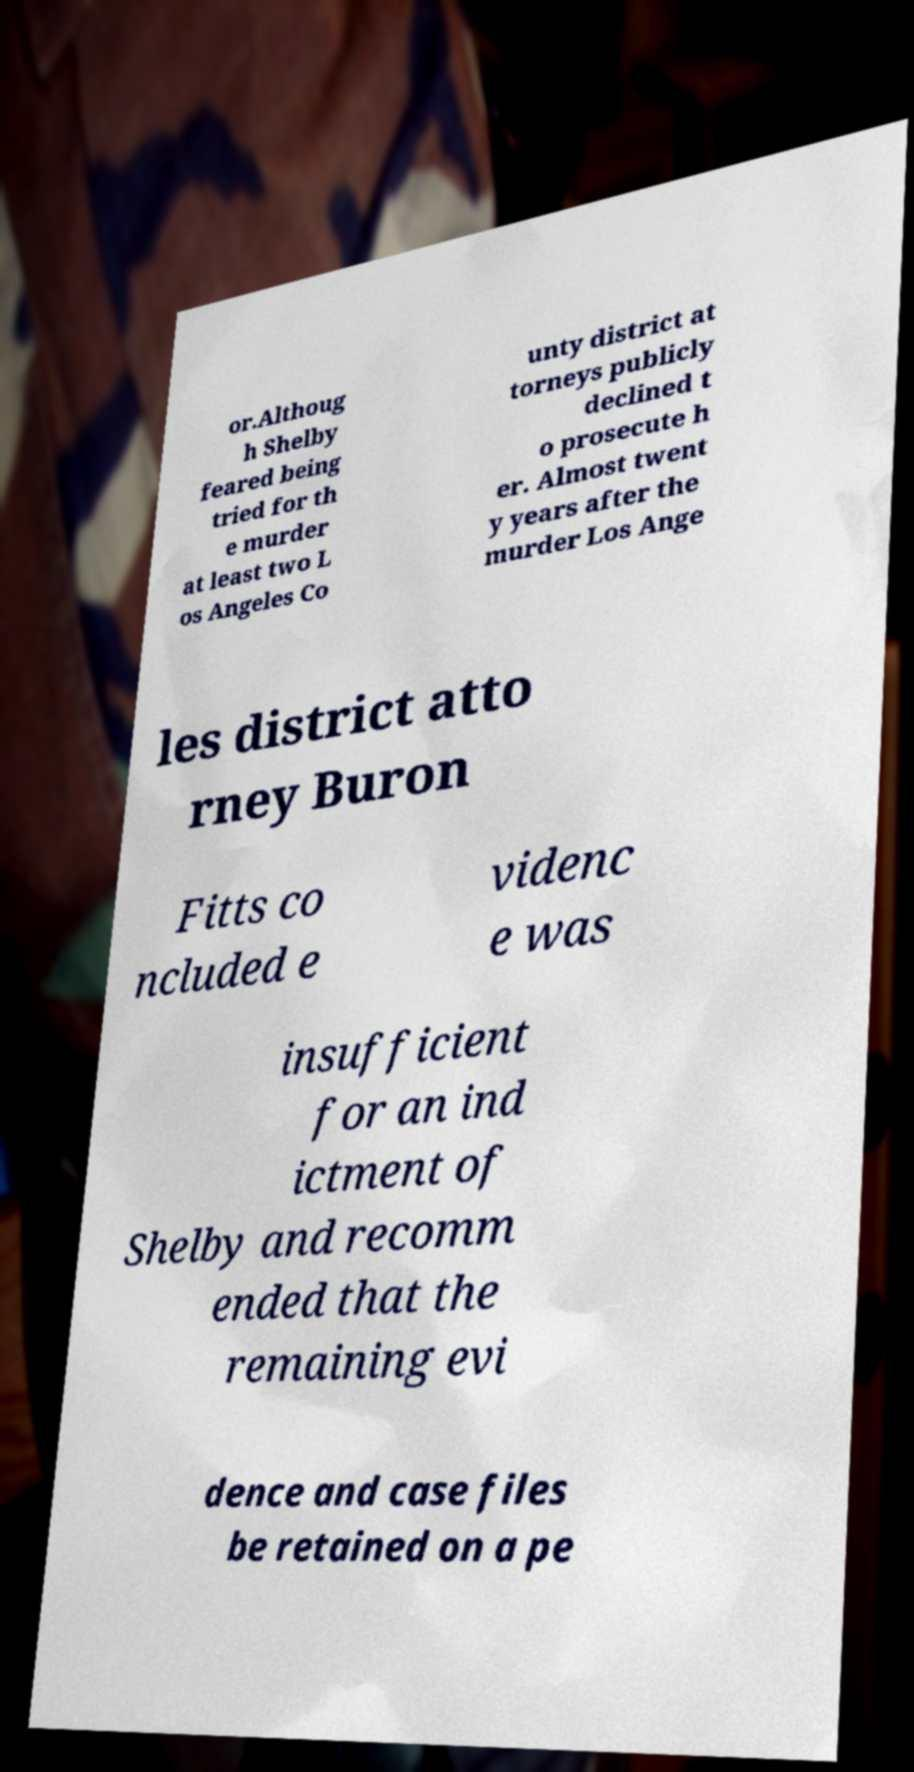Can you accurately transcribe the text from the provided image for me? or.Althoug h Shelby feared being tried for th e murder at least two L os Angeles Co unty district at torneys publicly declined t o prosecute h er. Almost twent y years after the murder Los Ange les district atto rney Buron Fitts co ncluded e videnc e was insufficient for an ind ictment of Shelby and recomm ended that the remaining evi dence and case files be retained on a pe 